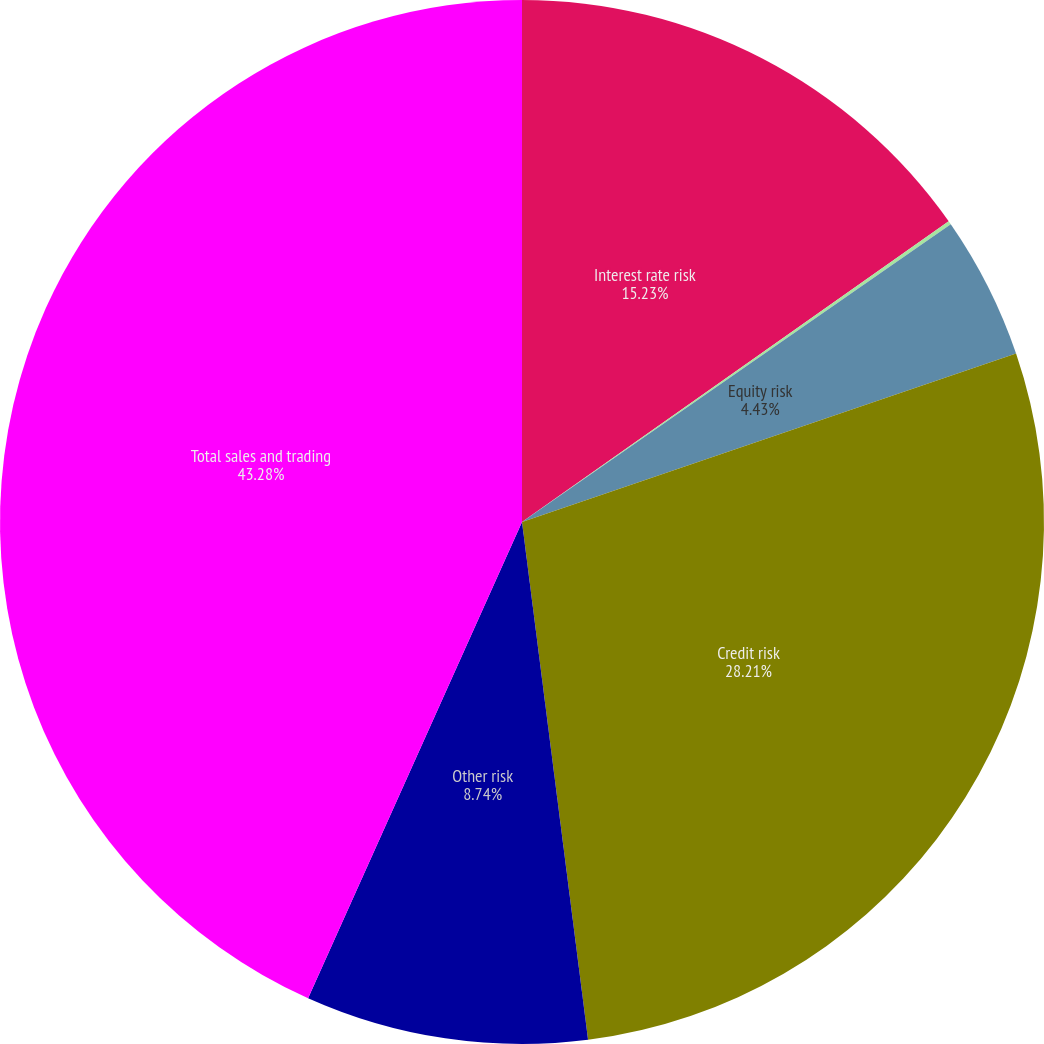Convert chart to OTSL. <chart><loc_0><loc_0><loc_500><loc_500><pie_chart><fcel>Interest rate risk<fcel>Foreign exchange risk<fcel>Equity risk<fcel>Credit risk<fcel>Other risk<fcel>Total sales and trading<nl><fcel>15.23%<fcel>0.11%<fcel>4.43%<fcel>28.21%<fcel>8.74%<fcel>43.28%<nl></chart> 